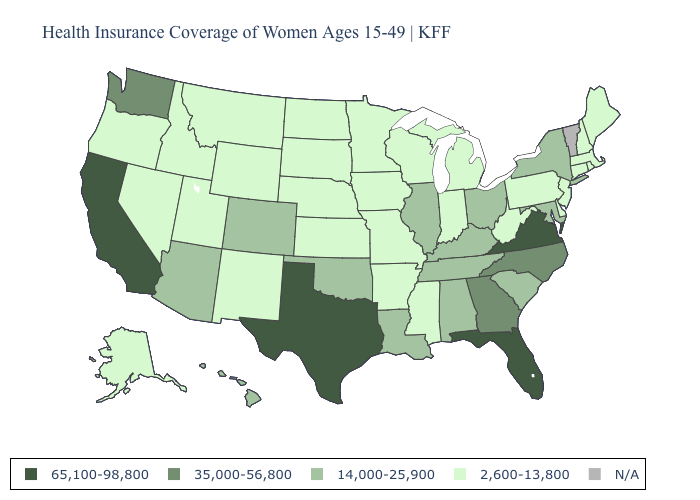Name the states that have a value in the range 65,100-98,800?
Write a very short answer. California, Florida, Texas, Virginia. Name the states that have a value in the range 14,000-25,900?
Answer briefly. Alabama, Arizona, Colorado, Hawaii, Illinois, Kentucky, Louisiana, Maryland, New York, Ohio, Oklahoma, South Carolina, Tennessee. Name the states that have a value in the range N/A?
Keep it brief. Vermont. What is the value of Arkansas?
Quick response, please. 2,600-13,800. Name the states that have a value in the range 2,600-13,800?
Give a very brief answer. Alaska, Arkansas, Connecticut, Delaware, Idaho, Indiana, Iowa, Kansas, Maine, Massachusetts, Michigan, Minnesota, Mississippi, Missouri, Montana, Nebraska, Nevada, New Hampshire, New Jersey, New Mexico, North Dakota, Oregon, Pennsylvania, Rhode Island, South Dakota, Utah, West Virginia, Wisconsin, Wyoming. What is the value of Alaska?
Answer briefly. 2,600-13,800. Which states have the lowest value in the South?
Concise answer only. Arkansas, Delaware, Mississippi, West Virginia. What is the lowest value in the MidWest?
Concise answer only. 2,600-13,800. What is the value of Tennessee?
Concise answer only. 14,000-25,900. Does Washington have the highest value in the USA?
Answer briefly. No. Does West Virginia have the highest value in the South?
Be succinct. No. Name the states that have a value in the range 65,100-98,800?
Concise answer only. California, Florida, Texas, Virginia. What is the value of Virginia?
Quick response, please. 65,100-98,800. What is the value of Colorado?
Short answer required. 14,000-25,900. 